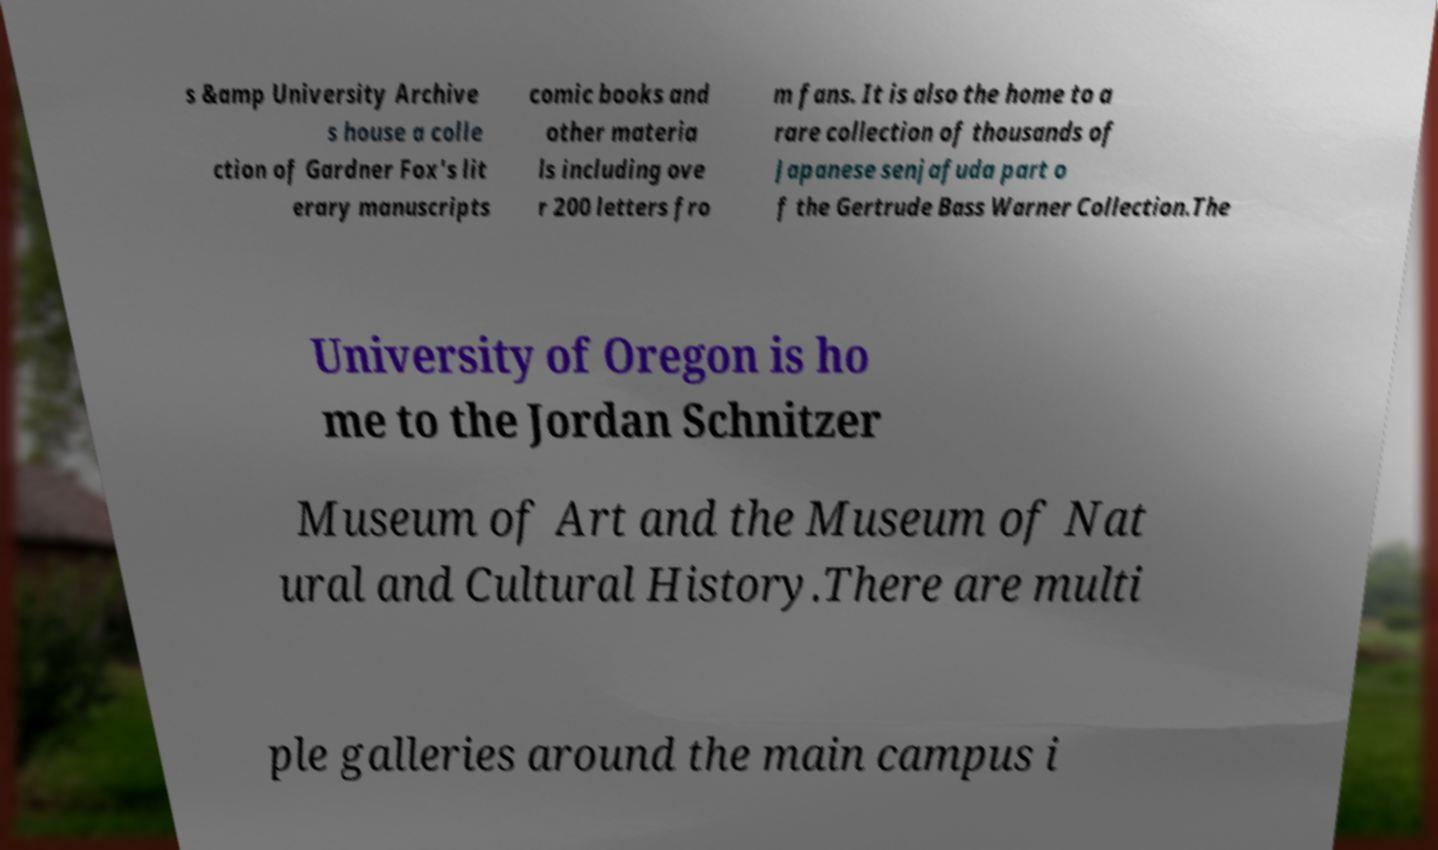For documentation purposes, I need the text within this image transcribed. Could you provide that? s &amp University Archive s house a colle ction of Gardner Fox's lit erary manuscripts comic books and other materia ls including ove r 200 letters fro m fans. It is also the home to a rare collection of thousands of Japanese senjafuda part o f the Gertrude Bass Warner Collection.The University of Oregon is ho me to the Jordan Schnitzer Museum of Art and the Museum of Nat ural and Cultural History.There are multi ple galleries around the main campus i 